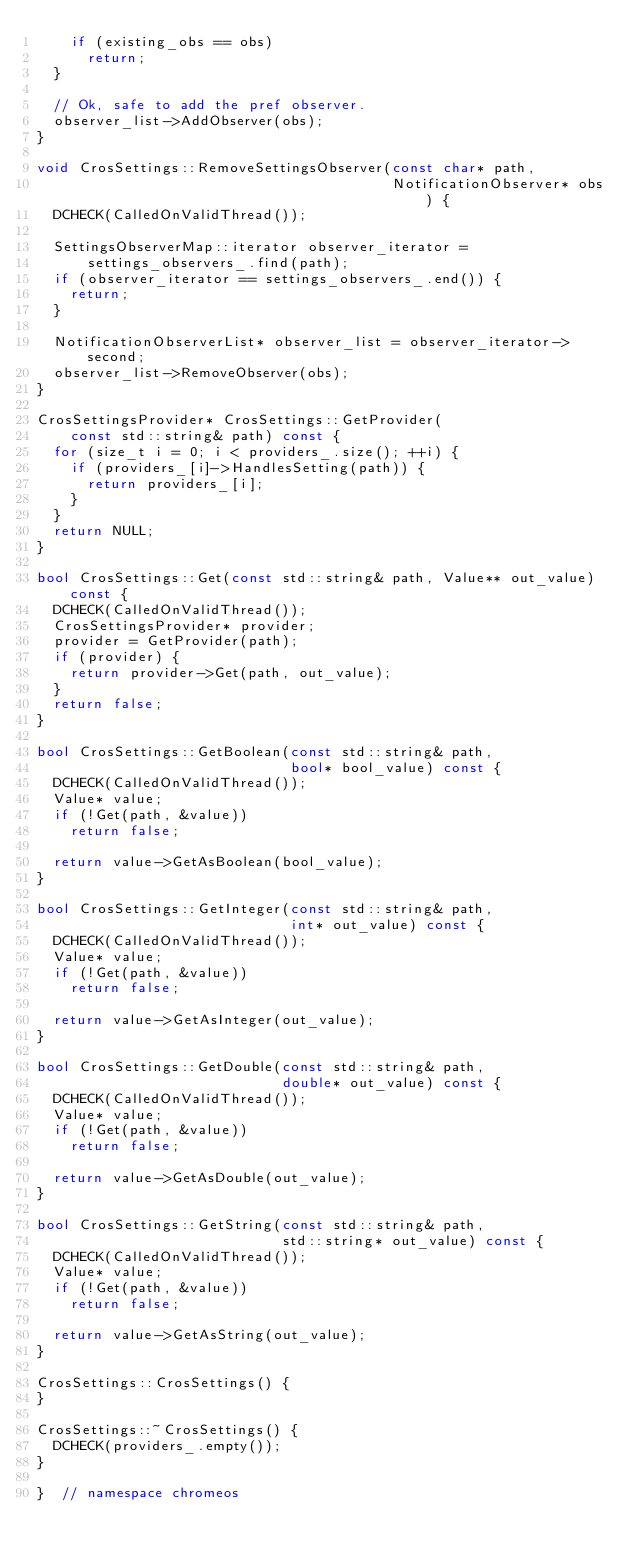<code> <loc_0><loc_0><loc_500><loc_500><_C++_>    if (existing_obs == obs)
      return;
  }

  // Ok, safe to add the pref observer.
  observer_list->AddObserver(obs);
}

void CrosSettings::RemoveSettingsObserver(const char* path,
                                          NotificationObserver* obs) {
  DCHECK(CalledOnValidThread());

  SettingsObserverMap::iterator observer_iterator =
      settings_observers_.find(path);
  if (observer_iterator == settings_observers_.end()) {
    return;
  }

  NotificationObserverList* observer_list = observer_iterator->second;
  observer_list->RemoveObserver(obs);
}

CrosSettingsProvider* CrosSettings::GetProvider(
    const std::string& path) const {
  for (size_t i = 0; i < providers_.size(); ++i) {
    if (providers_[i]->HandlesSetting(path)) {
      return providers_[i];
    }
  }
  return NULL;
}

bool CrosSettings::Get(const std::string& path, Value** out_value) const {
  DCHECK(CalledOnValidThread());
  CrosSettingsProvider* provider;
  provider = GetProvider(path);
  if (provider) {
    return provider->Get(path, out_value);
  }
  return false;
}

bool CrosSettings::GetBoolean(const std::string& path,
                              bool* bool_value) const {
  DCHECK(CalledOnValidThread());
  Value* value;
  if (!Get(path, &value))
    return false;

  return value->GetAsBoolean(bool_value);
}

bool CrosSettings::GetInteger(const std::string& path,
                              int* out_value) const {
  DCHECK(CalledOnValidThread());
  Value* value;
  if (!Get(path, &value))
    return false;

  return value->GetAsInteger(out_value);
}

bool CrosSettings::GetDouble(const std::string& path,
                             double* out_value) const {
  DCHECK(CalledOnValidThread());
  Value* value;
  if (!Get(path, &value))
    return false;

  return value->GetAsDouble(out_value);
}

bool CrosSettings::GetString(const std::string& path,
                             std::string* out_value) const {
  DCHECK(CalledOnValidThread());
  Value* value;
  if (!Get(path, &value))
    return false;

  return value->GetAsString(out_value);
}

CrosSettings::CrosSettings() {
}

CrosSettings::~CrosSettings() {
  DCHECK(providers_.empty());
}

}  // namespace chromeos
</code> 